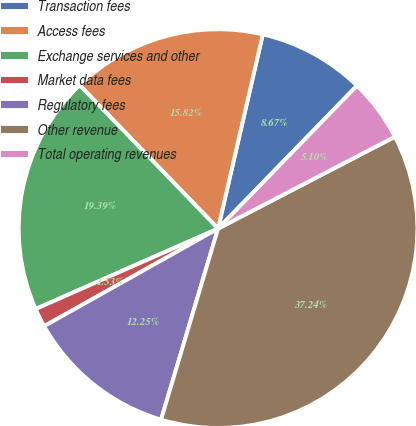Convert chart to OTSL. <chart><loc_0><loc_0><loc_500><loc_500><pie_chart><fcel>Transaction fees<fcel>Access fees<fcel>Exchange services and other<fcel>Market data fees<fcel>Regulatory fees<fcel>Other revenue<fcel>Total operating revenues<nl><fcel>8.67%<fcel>15.82%<fcel>19.39%<fcel>1.53%<fcel>12.25%<fcel>37.24%<fcel>5.1%<nl></chart> 